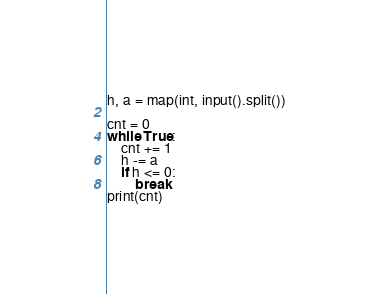<code> <loc_0><loc_0><loc_500><loc_500><_Python_>h, a = map(int, input().split())

cnt = 0
while True:
    cnt += 1
    h -= a
    if h <= 0:
        break
print(cnt)
</code> 